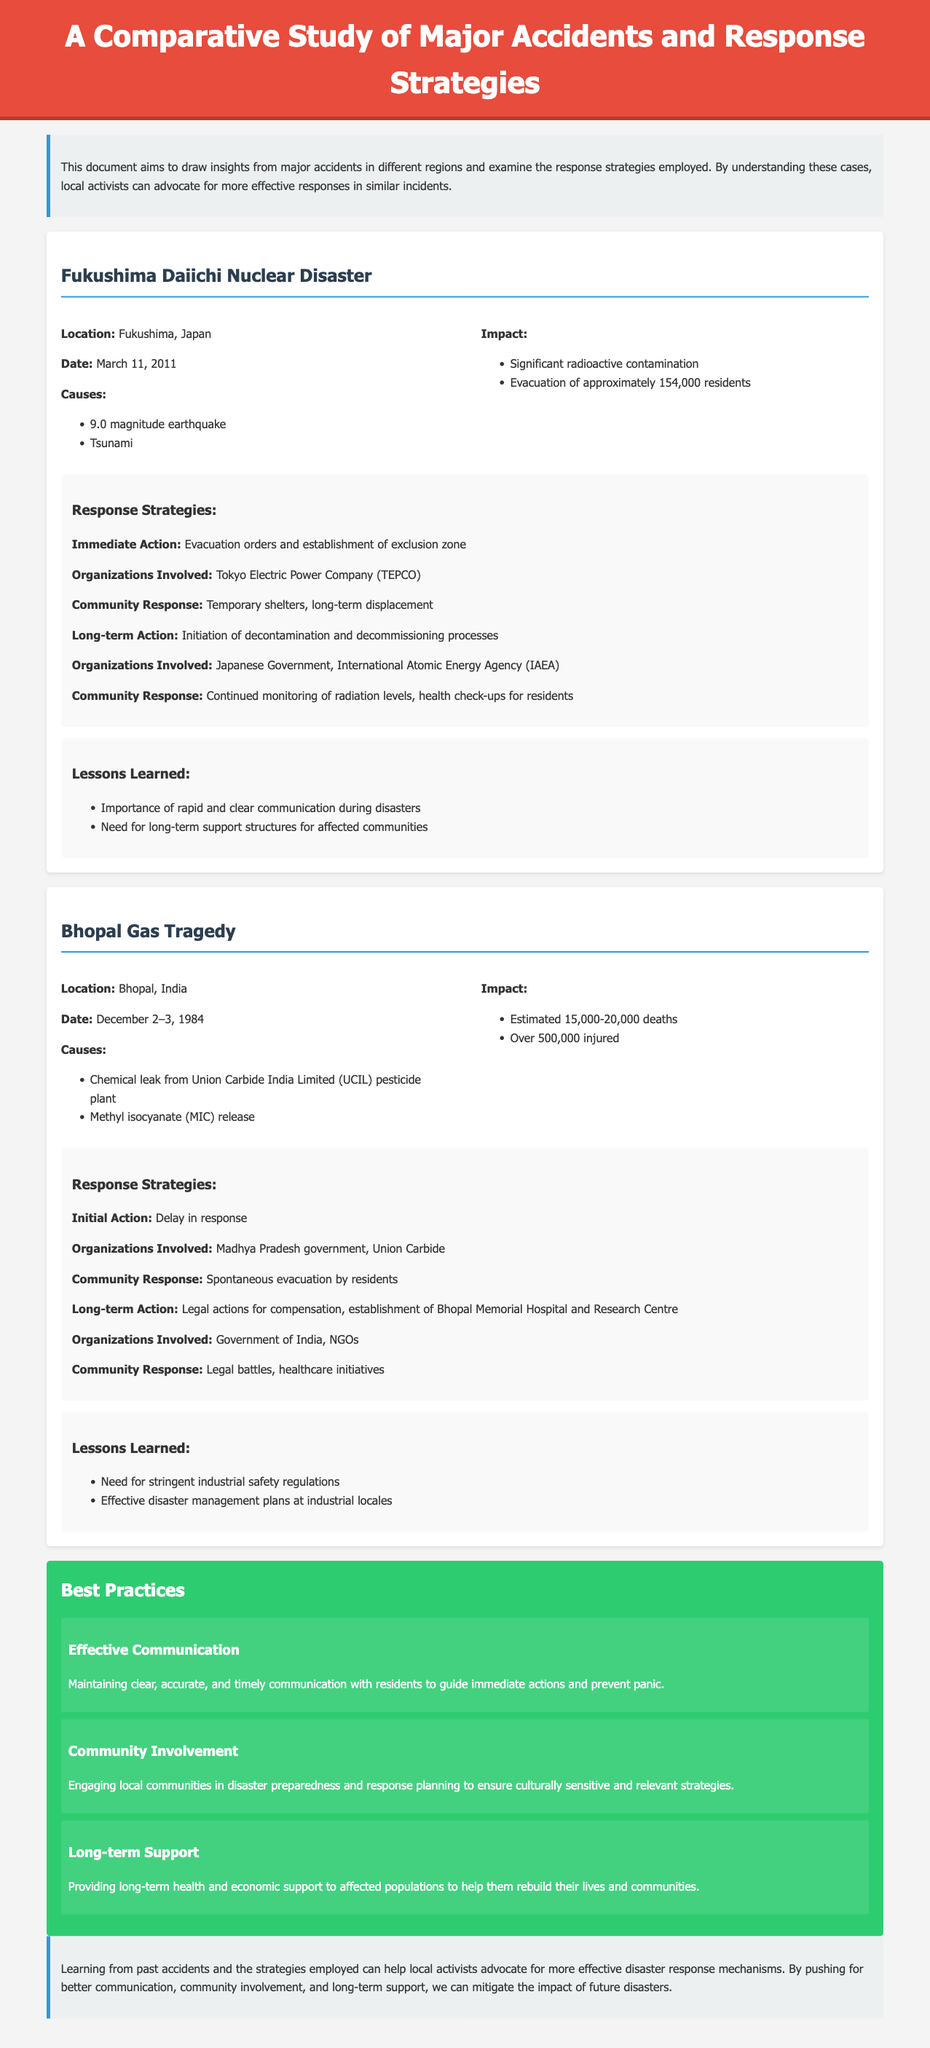What was the date of the Fukushima Daiichi Nuclear Disaster? The document specifies that the Fukushima Daiichi Nuclear Disaster occurred on March 11, 2011.
Answer: March 11, 2011 How many residents were evacuated during the Fukushima disaster? It states that approximately 154,000 residents were evacuated during the incident.
Answer: 154,000 What was the initial response strategy for the Bhopal Gas Tragedy? The document indicates that the initial response was delayed, highlighting a crucial aspect of the disaster management.
Answer: Delay in response Which organization was involved in the response to the Fukushima disaster? The document mentions Tokyo Electric Power Company (TEPCO) as one of the organizations involved in the Fukushima disaster response.
Answer: Tokyo Electric Power Company (TEPCO) What key lesson was learned from the Bhopal Gas Tragedy? The lessons learned emphasize the need for stringent industrial safety regulations, which is crucial for preventing future tragedies.
Answer: Need for stringent industrial safety regulations What type of communication is considered a best practice during disasters? The document outlines that maintaining clear, accurate, and timely communication is essential for effective disaster management.
Answer: Effective Communication How many deaths were estimated from the Bhopal Gas Tragedy? According to the document, the estimate for deaths resulting from the Bhopal Gas Tragedy is between 15,000 and 20,000.
Answer: 15,000-20,000 What long-term action was initiated after the Fukushima disaster? The document states that long-term actions included the initiation of decontamination and decommissioning processes.
Answer: Decontamination and decommissioning processes Which aspect is highlighted for community involvement during disasters? Community involvement is emphasized in engaging local communities in disaster preparedness and response planning.
Answer: Community Involvement 